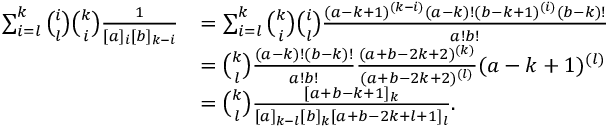Convert formula to latex. <formula><loc_0><loc_0><loc_500><loc_500>\begin{array} { r l } { \sum _ { i = l } ^ { k } \binom { i } { l } \binom { k } { i } \frac { 1 } { [ a ] _ { i } [ b ] _ { k - i } } } & { = \sum _ { i = l } ^ { k } \binom { k } { i } \binom { i } { l } \frac { ( a - k + 1 ) ^ { ( k - i ) } ( a - k ) ! ( b - k + 1 ) ^ { ( i ) } ( b - k ) ! } { a ! b ! } } \\ & { = \binom { k } { l } \frac { ( a - k ) ! ( b - k ) ! } { a ! b ! } \frac { ( a + b - 2 k + 2 ) ^ { ( k ) } } { ( a + b - 2 k + 2 ) ^ { ( l ) } } ( a - k + 1 ) ^ { ( l ) } } \\ & { = \binom { k } { l } \frac { [ a + b - k + 1 ] _ { k } } { [ a ] _ { k - l } [ b ] _ { k } [ a + b - 2 k + l + 1 ] _ { l } } . } \end{array}</formula> 